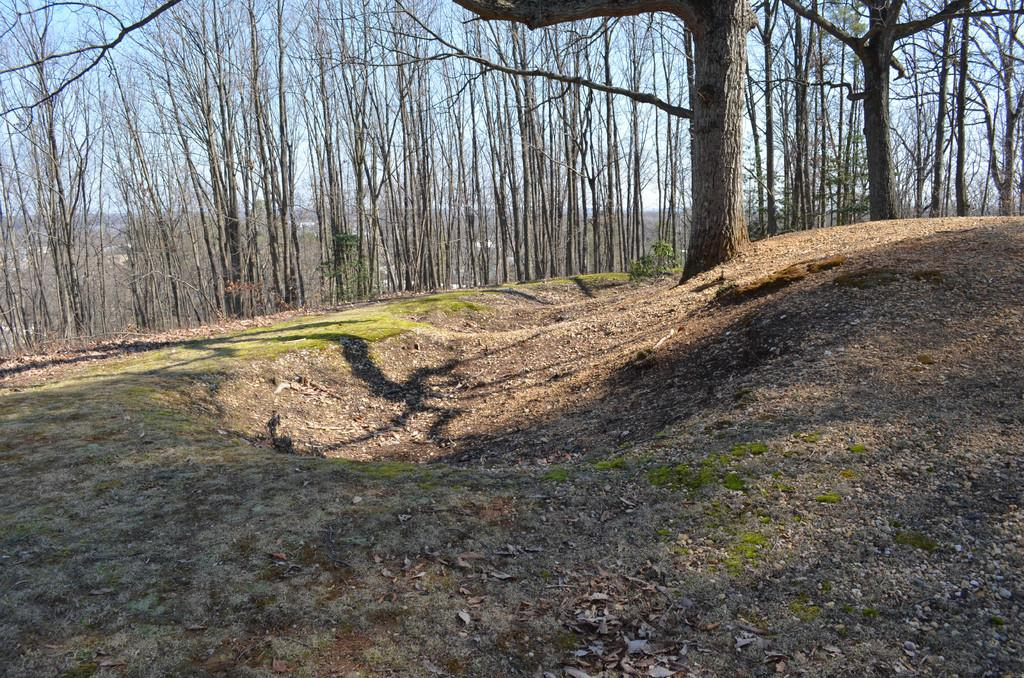What type of ground surface is visible in the image? There is grass on the ground in the image. What else can be seen on the ground? There is litter on the ground in the image. What can be seen in the background of the image? There are trees and the sky visible in the background of the image. How many books are being read by the men in the image? There are no men or books present in the image. 